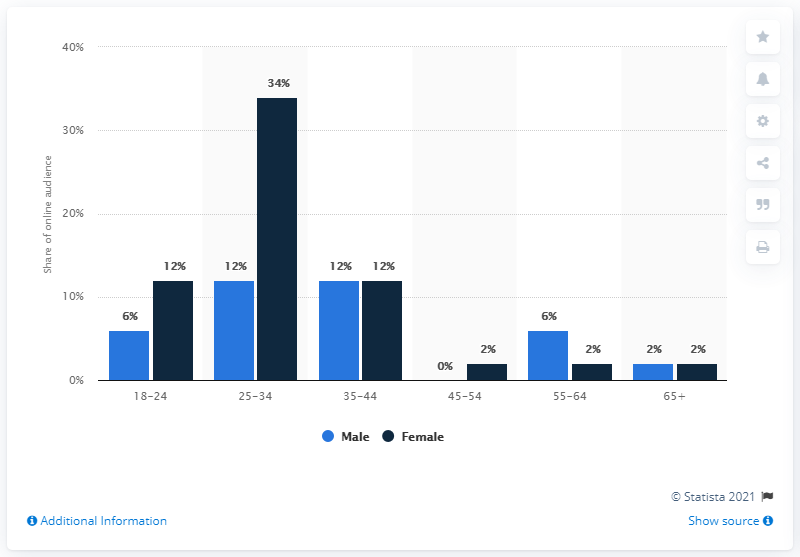Which age group shows the biggest difference in gender? In the provided chart, the age group of 25-34 displays the most significant difference in gender distribution, with males representing 34% of the total audience compared to a much smaller percentage for females. 